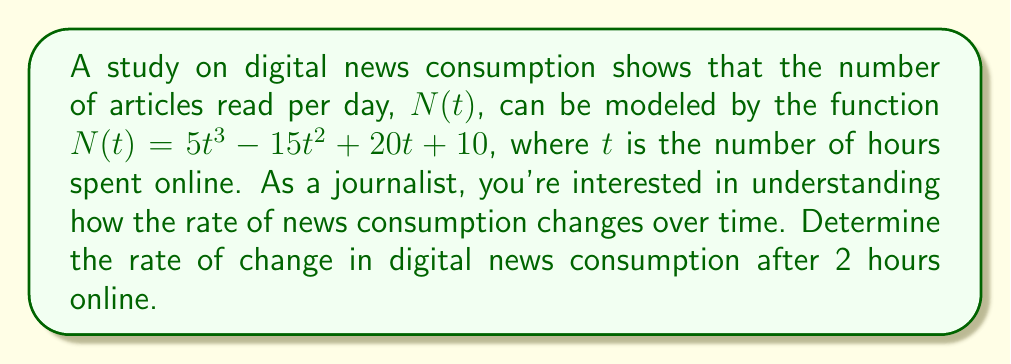Show me your answer to this math problem. To solve this problem, we need to follow these steps:

1) The rate of change in digital news consumption is represented by the derivative of the function $N(t)$.

2) Let's first find the derivative of $N(t)$:

   $$\frac{d}{dt}N(t) = \frac{d}{dt}(5t^3 - 15t^2 + 20t + 10)$$
   
   $$N'(t) = 15t^2 - 30t + 20$$

3) This derivative, $N'(t)$, represents the instantaneous rate of change of news consumption at any given time $t$.

4) We're asked to find the rate of change after 2 hours online. So, we need to evaluate $N'(t)$ at $t = 2$:

   $$N'(2) = 15(2)^2 - 30(2) + 20$$
   
   $$N'(2) = 15(4) - 60 + 20$$
   
   $$N'(2) = 60 - 60 + 20 = 20$$

5) Therefore, after 2 hours online, the rate of change in digital news consumption is 20 articles per hour.

This result indicates that at the 2-hour mark, digital news consumption is increasing at a rate of 20 articles per hour, which is valuable information for a journalist analyzing trends in online news readership.
Answer: The rate of change in digital news consumption after 2 hours online is 20 articles per hour. 